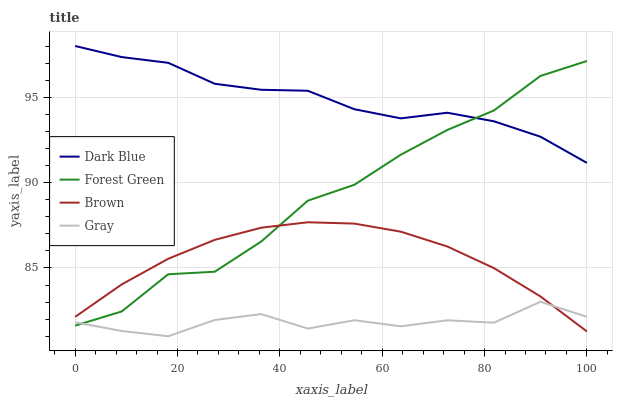Does Gray have the minimum area under the curve?
Answer yes or no. Yes. Does Dark Blue have the maximum area under the curve?
Answer yes or no. Yes. Does Forest Green have the minimum area under the curve?
Answer yes or no. No. Does Forest Green have the maximum area under the curve?
Answer yes or no. No. Is Brown the smoothest?
Answer yes or no. Yes. Is Forest Green the roughest?
Answer yes or no. Yes. Is Gray the smoothest?
Answer yes or no. No. Is Gray the roughest?
Answer yes or no. No. Does Forest Green have the lowest value?
Answer yes or no. No. Does Dark Blue have the highest value?
Answer yes or no. Yes. Does Forest Green have the highest value?
Answer yes or no. No. Is Brown less than Dark Blue?
Answer yes or no. Yes. Is Dark Blue greater than Gray?
Answer yes or no. Yes. Does Dark Blue intersect Forest Green?
Answer yes or no. Yes. Is Dark Blue less than Forest Green?
Answer yes or no. No. Is Dark Blue greater than Forest Green?
Answer yes or no. No. Does Brown intersect Dark Blue?
Answer yes or no. No. 